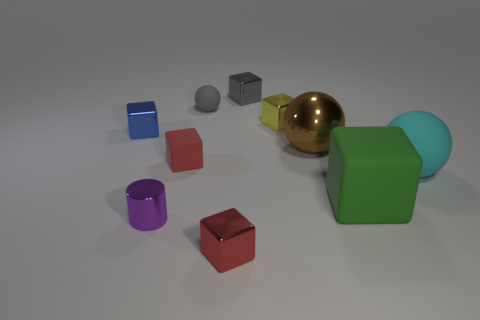Subtract all gray cubes. How many cubes are left? 5 Subtract all small blue shiny blocks. How many blocks are left? 5 Subtract all green cubes. Subtract all red spheres. How many cubes are left? 5 Subtract all cylinders. How many objects are left? 9 Add 5 rubber blocks. How many rubber blocks are left? 7 Add 7 red rubber cubes. How many red rubber cubes exist? 8 Subtract 0 yellow spheres. How many objects are left? 10 Subtract all large gray matte spheres. Subtract all blue blocks. How many objects are left? 9 